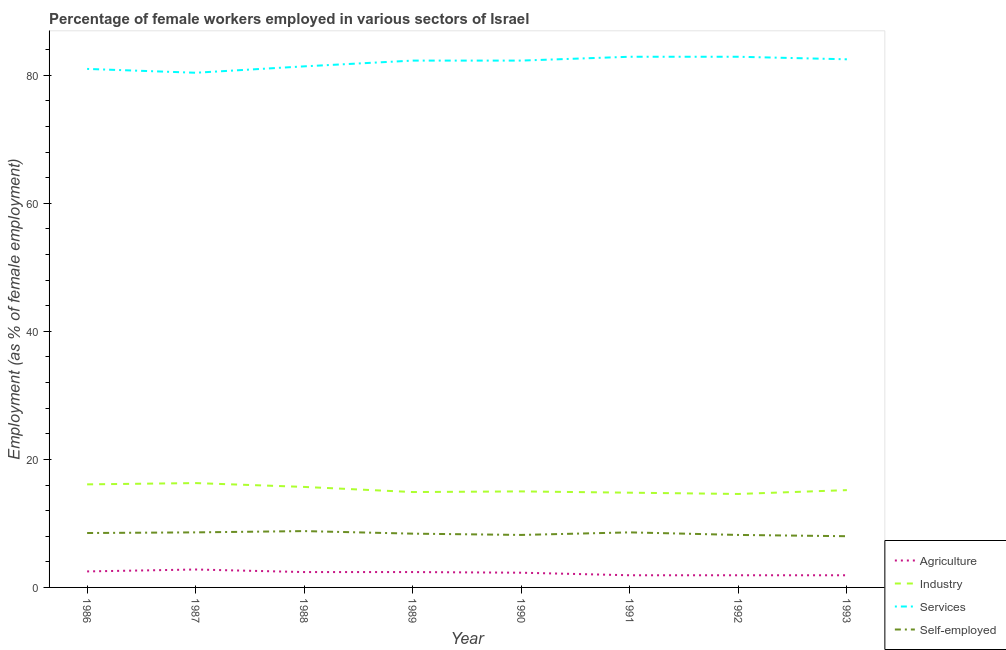How many different coloured lines are there?
Your answer should be very brief. 4. Is the number of lines equal to the number of legend labels?
Keep it short and to the point. Yes. What is the percentage of female workers in industry in 1991?
Your response must be concise. 14.8. Across all years, what is the maximum percentage of female workers in industry?
Provide a succinct answer. 16.3. What is the total percentage of female workers in industry in the graph?
Offer a terse response. 122.6. What is the difference between the percentage of self employed female workers in 1991 and that in 1993?
Give a very brief answer. 0.6. What is the difference between the percentage of self employed female workers in 1992 and the percentage of female workers in services in 1993?
Provide a short and direct response. -74.3. What is the average percentage of female workers in agriculture per year?
Your answer should be compact. 2.26. In the year 1992, what is the difference between the percentage of female workers in services and percentage of female workers in industry?
Make the answer very short. 68.3. What is the ratio of the percentage of female workers in agriculture in 1987 to that in 1990?
Make the answer very short. 1.22. Is the difference between the percentage of female workers in industry in 1986 and 1991 greater than the difference between the percentage of female workers in agriculture in 1986 and 1991?
Keep it short and to the point. Yes. What is the difference between the highest and the second highest percentage of female workers in services?
Offer a terse response. 0. What is the difference between the highest and the lowest percentage of female workers in services?
Keep it short and to the point. 2.5. In how many years, is the percentage of female workers in services greater than the average percentage of female workers in services taken over all years?
Provide a succinct answer. 5. Is the sum of the percentage of female workers in agriculture in 1988 and 1989 greater than the maximum percentage of self employed female workers across all years?
Your response must be concise. No. Is it the case that in every year, the sum of the percentage of female workers in agriculture and percentage of self employed female workers is greater than the sum of percentage of female workers in industry and percentage of female workers in services?
Offer a very short reply. Yes. Is it the case that in every year, the sum of the percentage of female workers in agriculture and percentage of female workers in industry is greater than the percentage of female workers in services?
Provide a short and direct response. No. Does the percentage of female workers in industry monotonically increase over the years?
Offer a terse response. No. Is the percentage of female workers in industry strictly less than the percentage of female workers in agriculture over the years?
Your answer should be compact. No. What is the difference between two consecutive major ticks on the Y-axis?
Give a very brief answer. 20. Are the values on the major ticks of Y-axis written in scientific E-notation?
Provide a succinct answer. No. Does the graph contain any zero values?
Provide a succinct answer. No. Does the graph contain grids?
Make the answer very short. No. How many legend labels are there?
Provide a succinct answer. 4. What is the title of the graph?
Give a very brief answer. Percentage of female workers employed in various sectors of Israel. What is the label or title of the X-axis?
Your answer should be very brief. Year. What is the label or title of the Y-axis?
Make the answer very short. Employment (as % of female employment). What is the Employment (as % of female employment) of Industry in 1986?
Your answer should be compact. 16.1. What is the Employment (as % of female employment) in Agriculture in 1987?
Offer a very short reply. 2.8. What is the Employment (as % of female employment) of Industry in 1987?
Your answer should be compact. 16.3. What is the Employment (as % of female employment) in Services in 1987?
Make the answer very short. 80.4. What is the Employment (as % of female employment) of Self-employed in 1987?
Your response must be concise. 8.6. What is the Employment (as % of female employment) in Agriculture in 1988?
Your answer should be compact. 2.4. What is the Employment (as % of female employment) of Industry in 1988?
Offer a very short reply. 15.7. What is the Employment (as % of female employment) of Services in 1988?
Provide a short and direct response. 81.4. What is the Employment (as % of female employment) of Self-employed in 1988?
Your response must be concise. 8.8. What is the Employment (as % of female employment) of Agriculture in 1989?
Provide a succinct answer. 2.4. What is the Employment (as % of female employment) in Industry in 1989?
Give a very brief answer. 14.9. What is the Employment (as % of female employment) of Services in 1989?
Make the answer very short. 82.3. What is the Employment (as % of female employment) in Self-employed in 1989?
Offer a very short reply. 8.4. What is the Employment (as % of female employment) of Agriculture in 1990?
Keep it short and to the point. 2.3. What is the Employment (as % of female employment) of Services in 1990?
Provide a succinct answer. 82.3. What is the Employment (as % of female employment) in Self-employed in 1990?
Give a very brief answer. 8.2. What is the Employment (as % of female employment) of Agriculture in 1991?
Make the answer very short. 1.9. What is the Employment (as % of female employment) of Industry in 1991?
Make the answer very short. 14.8. What is the Employment (as % of female employment) in Services in 1991?
Your response must be concise. 82.9. What is the Employment (as % of female employment) of Self-employed in 1991?
Your answer should be very brief. 8.6. What is the Employment (as % of female employment) in Agriculture in 1992?
Offer a terse response. 1.9. What is the Employment (as % of female employment) of Industry in 1992?
Make the answer very short. 14.6. What is the Employment (as % of female employment) of Services in 1992?
Your answer should be compact. 82.9. What is the Employment (as % of female employment) of Self-employed in 1992?
Offer a very short reply. 8.2. What is the Employment (as % of female employment) of Agriculture in 1993?
Your response must be concise. 1.9. What is the Employment (as % of female employment) in Industry in 1993?
Your answer should be very brief. 15.2. What is the Employment (as % of female employment) of Services in 1993?
Provide a short and direct response. 82.5. What is the Employment (as % of female employment) in Self-employed in 1993?
Give a very brief answer. 8. Across all years, what is the maximum Employment (as % of female employment) of Agriculture?
Offer a very short reply. 2.8. Across all years, what is the maximum Employment (as % of female employment) in Industry?
Your answer should be very brief. 16.3. Across all years, what is the maximum Employment (as % of female employment) in Services?
Offer a terse response. 82.9. Across all years, what is the maximum Employment (as % of female employment) in Self-employed?
Your answer should be very brief. 8.8. Across all years, what is the minimum Employment (as % of female employment) in Agriculture?
Keep it short and to the point. 1.9. Across all years, what is the minimum Employment (as % of female employment) of Industry?
Provide a short and direct response. 14.6. Across all years, what is the minimum Employment (as % of female employment) in Services?
Offer a very short reply. 80.4. What is the total Employment (as % of female employment) in Agriculture in the graph?
Offer a very short reply. 18.1. What is the total Employment (as % of female employment) of Industry in the graph?
Your response must be concise. 122.6. What is the total Employment (as % of female employment) in Services in the graph?
Provide a short and direct response. 655.7. What is the total Employment (as % of female employment) in Self-employed in the graph?
Provide a succinct answer. 67.3. What is the difference between the Employment (as % of female employment) in Industry in 1986 and that in 1987?
Your answer should be very brief. -0.2. What is the difference between the Employment (as % of female employment) of Self-employed in 1986 and that in 1987?
Give a very brief answer. -0.1. What is the difference between the Employment (as % of female employment) of Agriculture in 1986 and that in 1988?
Keep it short and to the point. 0.1. What is the difference between the Employment (as % of female employment) in Industry in 1986 and that in 1988?
Provide a succinct answer. 0.4. What is the difference between the Employment (as % of female employment) in Industry in 1986 and that in 1990?
Your response must be concise. 1.1. What is the difference between the Employment (as % of female employment) in Services in 1986 and that in 1990?
Ensure brevity in your answer.  -1.3. What is the difference between the Employment (as % of female employment) of Industry in 1986 and that in 1991?
Make the answer very short. 1.3. What is the difference between the Employment (as % of female employment) of Self-employed in 1986 and that in 1991?
Provide a short and direct response. -0.1. What is the difference between the Employment (as % of female employment) in Agriculture in 1986 and that in 1992?
Offer a very short reply. 0.6. What is the difference between the Employment (as % of female employment) in Services in 1986 and that in 1992?
Your answer should be very brief. -1.9. What is the difference between the Employment (as % of female employment) of Services in 1986 and that in 1993?
Make the answer very short. -1.5. What is the difference between the Employment (as % of female employment) in Agriculture in 1987 and that in 1988?
Ensure brevity in your answer.  0.4. What is the difference between the Employment (as % of female employment) in Industry in 1987 and that in 1988?
Keep it short and to the point. 0.6. What is the difference between the Employment (as % of female employment) of Self-employed in 1987 and that in 1988?
Ensure brevity in your answer.  -0.2. What is the difference between the Employment (as % of female employment) of Industry in 1987 and that in 1989?
Ensure brevity in your answer.  1.4. What is the difference between the Employment (as % of female employment) of Self-employed in 1987 and that in 1989?
Your answer should be compact. 0.2. What is the difference between the Employment (as % of female employment) in Industry in 1987 and that in 1990?
Provide a short and direct response. 1.3. What is the difference between the Employment (as % of female employment) of Industry in 1987 and that in 1991?
Your response must be concise. 1.5. What is the difference between the Employment (as % of female employment) of Services in 1987 and that in 1991?
Your response must be concise. -2.5. What is the difference between the Employment (as % of female employment) in Self-employed in 1987 and that in 1991?
Your answer should be compact. 0. What is the difference between the Employment (as % of female employment) in Agriculture in 1987 and that in 1992?
Offer a very short reply. 0.9. What is the difference between the Employment (as % of female employment) in Industry in 1987 and that in 1992?
Ensure brevity in your answer.  1.7. What is the difference between the Employment (as % of female employment) in Services in 1987 and that in 1992?
Ensure brevity in your answer.  -2.5. What is the difference between the Employment (as % of female employment) in Agriculture in 1987 and that in 1993?
Your answer should be very brief. 0.9. What is the difference between the Employment (as % of female employment) of Industry in 1987 and that in 1993?
Provide a short and direct response. 1.1. What is the difference between the Employment (as % of female employment) of Self-employed in 1987 and that in 1993?
Provide a succinct answer. 0.6. What is the difference between the Employment (as % of female employment) in Industry in 1988 and that in 1989?
Your response must be concise. 0.8. What is the difference between the Employment (as % of female employment) in Industry in 1988 and that in 1991?
Give a very brief answer. 0.9. What is the difference between the Employment (as % of female employment) in Self-employed in 1988 and that in 1991?
Make the answer very short. 0.2. What is the difference between the Employment (as % of female employment) in Services in 1988 and that in 1992?
Ensure brevity in your answer.  -1.5. What is the difference between the Employment (as % of female employment) in Self-employed in 1988 and that in 1992?
Give a very brief answer. 0.6. What is the difference between the Employment (as % of female employment) of Agriculture in 1988 and that in 1993?
Give a very brief answer. 0.5. What is the difference between the Employment (as % of female employment) of Self-employed in 1988 and that in 1993?
Offer a very short reply. 0.8. What is the difference between the Employment (as % of female employment) in Services in 1989 and that in 1990?
Offer a very short reply. 0. What is the difference between the Employment (as % of female employment) in Agriculture in 1989 and that in 1991?
Make the answer very short. 0.5. What is the difference between the Employment (as % of female employment) in Self-employed in 1989 and that in 1991?
Your response must be concise. -0.2. What is the difference between the Employment (as % of female employment) in Agriculture in 1989 and that in 1992?
Provide a succinct answer. 0.5. What is the difference between the Employment (as % of female employment) in Agriculture in 1989 and that in 1993?
Your response must be concise. 0.5. What is the difference between the Employment (as % of female employment) in Services in 1989 and that in 1993?
Keep it short and to the point. -0.2. What is the difference between the Employment (as % of female employment) of Industry in 1990 and that in 1991?
Offer a very short reply. 0.2. What is the difference between the Employment (as % of female employment) of Services in 1990 and that in 1992?
Your response must be concise. -0.6. What is the difference between the Employment (as % of female employment) in Self-employed in 1990 and that in 1992?
Provide a succinct answer. 0. What is the difference between the Employment (as % of female employment) in Industry in 1990 and that in 1993?
Offer a very short reply. -0.2. What is the difference between the Employment (as % of female employment) of Services in 1991 and that in 1992?
Provide a short and direct response. 0. What is the difference between the Employment (as % of female employment) of Self-employed in 1991 and that in 1992?
Ensure brevity in your answer.  0.4. What is the difference between the Employment (as % of female employment) in Industry in 1991 and that in 1993?
Your answer should be compact. -0.4. What is the difference between the Employment (as % of female employment) in Services in 1992 and that in 1993?
Keep it short and to the point. 0.4. What is the difference between the Employment (as % of female employment) in Agriculture in 1986 and the Employment (as % of female employment) in Industry in 1987?
Provide a succinct answer. -13.8. What is the difference between the Employment (as % of female employment) in Agriculture in 1986 and the Employment (as % of female employment) in Services in 1987?
Ensure brevity in your answer.  -77.9. What is the difference between the Employment (as % of female employment) in Agriculture in 1986 and the Employment (as % of female employment) in Self-employed in 1987?
Offer a terse response. -6.1. What is the difference between the Employment (as % of female employment) of Industry in 1986 and the Employment (as % of female employment) of Services in 1987?
Give a very brief answer. -64.3. What is the difference between the Employment (as % of female employment) in Services in 1986 and the Employment (as % of female employment) in Self-employed in 1987?
Provide a succinct answer. 72.4. What is the difference between the Employment (as % of female employment) of Agriculture in 1986 and the Employment (as % of female employment) of Industry in 1988?
Your answer should be very brief. -13.2. What is the difference between the Employment (as % of female employment) in Agriculture in 1986 and the Employment (as % of female employment) in Services in 1988?
Give a very brief answer. -78.9. What is the difference between the Employment (as % of female employment) in Industry in 1986 and the Employment (as % of female employment) in Services in 1988?
Your response must be concise. -65.3. What is the difference between the Employment (as % of female employment) of Services in 1986 and the Employment (as % of female employment) of Self-employed in 1988?
Provide a short and direct response. 72.2. What is the difference between the Employment (as % of female employment) in Agriculture in 1986 and the Employment (as % of female employment) in Services in 1989?
Ensure brevity in your answer.  -79.8. What is the difference between the Employment (as % of female employment) in Agriculture in 1986 and the Employment (as % of female employment) in Self-employed in 1989?
Give a very brief answer. -5.9. What is the difference between the Employment (as % of female employment) in Industry in 1986 and the Employment (as % of female employment) in Services in 1989?
Provide a succinct answer. -66.2. What is the difference between the Employment (as % of female employment) of Services in 1986 and the Employment (as % of female employment) of Self-employed in 1989?
Your answer should be very brief. 72.6. What is the difference between the Employment (as % of female employment) in Agriculture in 1986 and the Employment (as % of female employment) in Industry in 1990?
Ensure brevity in your answer.  -12.5. What is the difference between the Employment (as % of female employment) of Agriculture in 1986 and the Employment (as % of female employment) of Services in 1990?
Provide a short and direct response. -79.8. What is the difference between the Employment (as % of female employment) in Agriculture in 1986 and the Employment (as % of female employment) in Self-employed in 1990?
Give a very brief answer. -5.7. What is the difference between the Employment (as % of female employment) in Industry in 1986 and the Employment (as % of female employment) in Services in 1990?
Provide a succinct answer. -66.2. What is the difference between the Employment (as % of female employment) in Industry in 1986 and the Employment (as % of female employment) in Self-employed in 1990?
Your response must be concise. 7.9. What is the difference between the Employment (as % of female employment) of Services in 1986 and the Employment (as % of female employment) of Self-employed in 1990?
Your answer should be very brief. 72.8. What is the difference between the Employment (as % of female employment) in Agriculture in 1986 and the Employment (as % of female employment) in Industry in 1991?
Keep it short and to the point. -12.3. What is the difference between the Employment (as % of female employment) in Agriculture in 1986 and the Employment (as % of female employment) in Services in 1991?
Your response must be concise. -80.4. What is the difference between the Employment (as % of female employment) in Agriculture in 1986 and the Employment (as % of female employment) in Self-employed in 1991?
Make the answer very short. -6.1. What is the difference between the Employment (as % of female employment) in Industry in 1986 and the Employment (as % of female employment) in Services in 1991?
Provide a short and direct response. -66.8. What is the difference between the Employment (as % of female employment) in Services in 1986 and the Employment (as % of female employment) in Self-employed in 1991?
Make the answer very short. 72.4. What is the difference between the Employment (as % of female employment) in Agriculture in 1986 and the Employment (as % of female employment) in Services in 1992?
Your answer should be very brief. -80.4. What is the difference between the Employment (as % of female employment) in Agriculture in 1986 and the Employment (as % of female employment) in Self-employed in 1992?
Give a very brief answer. -5.7. What is the difference between the Employment (as % of female employment) of Industry in 1986 and the Employment (as % of female employment) of Services in 1992?
Offer a very short reply. -66.8. What is the difference between the Employment (as % of female employment) in Services in 1986 and the Employment (as % of female employment) in Self-employed in 1992?
Give a very brief answer. 72.8. What is the difference between the Employment (as % of female employment) in Agriculture in 1986 and the Employment (as % of female employment) in Services in 1993?
Offer a terse response. -80. What is the difference between the Employment (as % of female employment) in Industry in 1986 and the Employment (as % of female employment) in Services in 1993?
Offer a very short reply. -66.4. What is the difference between the Employment (as % of female employment) in Agriculture in 1987 and the Employment (as % of female employment) in Industry in 1988?
Make the answer very short. -12.9. What is the difference between the Employment (as % of female employment) of Agriculture in 1987 and the Employment (as % of female employment) of Services in 1988?
Offer a terse response. -78.6. What is the difference between the Employment (as % of female employment) of Agriculture in 1987 and the Employment (as % of female employment) of Self-employed in 1988?
Provide a short and direct response. -6. What is the difference between the Employment (as % of female employment) in Industry in 1987 and the Employment (as % of female employment) in Services in 1988?
Provide a short and direct response. -65.1. What is the difference between the Employment (as % of female employment) in Industry in 1987 and the Employment (as % of female employment) in Self-employed in 1988?
Offer a very short reply. 7.5. What is the difference between the Employment (as % of female employment) in Services in 1987 and the Employment (as % of female employment) in Self-employed in 1988?
Offer a terse response. 71.6. What is the difference between the Employment (as % of female employment) of Agriculture in 1987 and the Employment (as % of female employment) of Services in 1989?
Your answer should be very brief. -79.5. What is the difference between the Employment (as % of female employment) of Industry in 1987 and the Employment (as % of female employment) of Services in 1989?
Provide a short and direct response. -66. What is the difference between the Employment (as % of female employment) of Agriculture in 1987 and the Employment (as % of female employment) of Services in 1990?
Make the answer very short. -79.5. What is the difference between the Employment (as % of female employment) in Industry in 1987 and the Employment (as % of female employment) in Services in 1990?
Your response must be concise. -66. What is the difference between the Employment (as % of female employment) in Services in 1987 and the Employment (as % of female employment) in Self-employed in 1990?
Offer a very short reply. 72.2. What is the difference between the Employment (as % of female employment) in Agriculture in 1987 and the Employment (as % of female employment) in Services in 1991?
Keep it short and to the point. -80.1. What is the difference between the Employment (as % of female employment) in Industry in 1987 and the Employment (as % of female employment) in Services in 1991?
Your response must be concise. -66.6. What is the difference between the Employment (as % of female employment) of Industry in 1987 and the Employment (as % of female employment) of Self-employed in 1991?
Provide a succinct answer. 7.7. What is the difference between the Employment (as % of female employment) in Services in 1987 and the Employment (as % of female employment) in Self-employed in 1991?
Your response must be concise. 71.8. What is the difference between the Employment (as % of female employment) in Agriculture in 1987 and the Employment (as % of female employment) in Services in 1992?
Provide a succinct answer. -80.1. What is the difference between the Employment (as % of female employment) of Agriculture in 1987 and the Employment (as % of female employment) of Self-employed in 1992?
Provide a short and direct response. -5.4. What is the difference between the Employment (as % of female employment) in Industry in 1987 and the Employment (as % of female employment) in Services in 1992?
Make the answer very short. -66.6. What is the difference between the Employment (as % of female employment) in Industry in 1987 and the Employment (as % of female employment) in Self-employed in 1992?
Your answer should be very brief. 8.1. What is the difference between the Employment (as % of female employment) of Services in 1987 and the Employment (as % of female employment) of Self-employed in 1992?
Offer a terse response. 72.2. What is the difference between the Employment (as % of female employment) in Agriculture in 1987 and the Employment (as % of female employment) in Industry in 1993?
Your response must be concise. -12.4. What is the difference between the Employment (as % of female employment) of Agriculture in 1987 and the Employment (as % of female employment) of Services in 1993?
Provide a short and direct response. -79.7. What is the difference between the Employment (as % of female employment) in Agriculture in 1987 and the Employment (as % of female employment) in Self-employed in 1993?
Your answer should be compact. -5.2. What is the difference between the Employment (as % of female employment) in Industry in 1987 and the Employment (as % of female employment) in Services in 1993?
Provide a succinct answer. -66.2. What is the difference between the Employment (as % of female employment) of Services in 1987 and the Employment (as % of female employment) of Self-employed in 1993?
Make the answer very short. 72.4. What is the difference between the Employment (as % of female employment) in Agriculture in 1988 and the Employment (as % of female employment) in Services in 1989?
Provide a succinct answer. -79.9. What is the difference between the Employment (as % of female employment) of Agriculture in 1988 and the Employment (as % of female employment) of Self-employed in 1989?
Provide a short and direct response. -6. What is the difference between the Employment (as % of female employment) of Industry in 1988 and the Employment (as % of female employment) of Services in 1989?
Keep it short and to the point. -66.6. What is the difference between the Employment (as % of female employment) of Industry in 1988 and the Employment (as % of female employment) of Self-employed in 1989?
Provide a short and direct response. 7.3. What is the difference between the Employment (as % of female employment) of Services in 1988 and the Employment (as % of female employment) of Self-employed in 1989?
Make the answer very short. 73. What is the difference between the Employment (as % of female employment) of Agriculture in 1988 and the Employment (as % of female employment) of Services in 1990?
Make the answer very short. -79.9. What is the difference between the Employment (as % of female employment) of Industry in 1988 and the Employment (as % of female employment) of Services in 1990?
Offer a very short reply. -66.6. What is the difference between the Employment (as % of female employment) of Services in 1988 and the Employment (as % of female employment) of Self-employed in 1990?
Your answer should be compact. 73.2. What is the difference between the Employment (as % of female employment) of Agriculture in 1988 and the Employment (as % of female employment) of Services in 1991?
Make the answer very short. -80.5. What is the difference between the Employment (as % of female employment) in Industry in 1988 and the Employment (as % of female employment) in Services in 1991?
Your answer should be very brief. -67.2. What is the difference between the Employment (as % of female employment) of Industry in 1988 and the Employment (as % of female employment) of Self-employed in 1991?
Offer a terse response. 7.1. What is the difference between the Employment (as % of female employment) of Services in 1988 and the Employment (as % of female employment) of Self-employed in 1991?
Your response must be concise. 72.8. What is the difference between the Employment (as % of female employment) in Agriculture in 1988 and the Employment (as % of female employment) in Services in 1992?
Provide a short and direct response. -80.5. What is the difference between the Employment (as % of female employment) of Agriculture in 1988 and the Employment (as % of female employment) of Self-employed in 1992?
Your answer should be very brief. -5.8. What is the difference between the Employment (as % of female employment) in Industry in 1988 and the Employment (as % of female employment) in Services in 1992?
Make the answer very short. -67.2. What is the difference between the Employment (as % of female employment) in Services in 1988 and the Employment (as % of female employment) in Self-employed in 1992?
Your answer should be very brief. 73.2. What is the difference between the Employment (as % of female employment) of Agriculture in 1988 and the Employment (as % of female employment) of Industry in 1993?
Provide a succinct answer. -12.8. What is the difference between the Employment (as % of female employment) in Agriculture in 1988 and the Employment (as % of female employment) in Services in 1993?
Provide a succinct answer. -80.1. What is the difference between the Employment (as % of female employment) of Agriculture in 1988 and the Employment (as % of female employment) of Self-employed in 1993?
Your answer should be very brief. -5.6. What is the difference between the Employment (as % of female employment) of Industry in 1988 and the Employment (as % of female employment) of Services in 1993?
Provide a succinct answer. -66.8. What is the difference between the Employment (as % of female employment) in Industry in 1988 and the Employment (as % of female employment) in Self-employed in 1993?
Ensure brevity in your answer.  7.7. What is the difference between the Employment (as % of female employment) of Services in 1988 and the Employment (as % of female employment) of Self-employed in 1993?
Offer a very short reply. 73.4. What is the difference between the Employment (as % of female employment) in Agriculture in 1989 and the Employment (as % of female employment) in Industry in 1990?
Provide a succinct answer. -12.6. What is the difference between the Employment (as % of female employment) in Agriculture in 1989 and the Employment (as % of female employment) in Services in 1990?
Provide a short and direct response. -79.9. What is the difference between the Employment (as % of female employment) of Industry in 1989 and the Employment (as % of female employment) of Services in 1990?
Offer a very short reply. -67.4. What is the difference between the Employment (as % of female employment) in Services in 1989 and the Employment (as % of female employment) in Self-employed in 1990?
Offer a terse response. 74.1. What is the difference between the Employment (as % of female employment) of Agriculture in 1989 and the Employment (as % of female employment) of Services in 1991?
Offer a very short reply. -80.5. What is the difference between the Employment (as % of female employment) of Industry in 1989 and the Employment (as % of female employment) of Services in 1991?
Provide a succinct answer. -68. What is the difference between the Employment (as % of female employment) of Services in 1989 and the Employment (as % of female employment) of Self-employed in 1991?
Offer a very short reply. 73.7. What is the difference between the Employment (as % of female employment) in Agriculture in 1989 and the Employment (as % of female employment) in Services in 1992?
Provide a short and direct response. -80.5. What is the difference between the Employment (as % of female employment) of Agriculture in 1989 and the Employment (as % of female employment) of Self-employed in 1992?
Your answer should be very brief. -5.8. What is the difference between the Employment (as % of female employment) in Industry in 1989 and the Employment (as % of female employment) in Services in 1992?
Make the answer very short. -68. What is the difference between the Employment (as % of female employment) in Industry in 1989 and the Employment (as % of female employment) in Self-employed in 1992?
Offer a very short reply. 6.7. What is the difference between the Employment (as % of female employment) in Services in 1989 and the Employment (as % of female employment) in Self-employed in 1992?
Give a very brief answer. 74.1. What is the difference between the Employment (as % of female employment) of Agriculture in 1989 and the Employment (as % of female employment) of Services in 1993?
Give a very brief answer. -80.1. What is the difference between the Employment (as % of female employment) in Agriculture in 1989 and the Employment (as % of female employment) in Self-employed in 1993?
Make the answer very short. -5.6. What is the difference between the Employment (as % of female employment) in Industry in 1989 and the Employment (as % of female employment) in Services in 1993?
Offer a terse response. -67.6. What is the difference between the Employment (as % of female employment) of Services in 1989 and the Employment (as % of female employment) of Self-employed in 1993?
Your response must be concise. 74.3. What is the difference between the Employment (as % of female employment) of Agriculture in 1990 and the Employment (as % of female employment) of Industry in 1991?
Give a very brief answer. -12.5. What is the difference between the Employment (as % of female employment) in Agriculture in 1990 and the Employment (as % of female employment) in Services in 1991?
Provide a short and direct response. -80.6. What is the difference between the Employment (as % of female employment) of Agriculture in 1990 and the Employment (as % of female employment) of Self-employed in 1991?
Provide a short and direct response. -6.3. What is the difference between the Employment (as % of female employment) in Industry in 1990 and the Employment (as % of female employment) in Services in 1991?
Offer a terse response. -67.9. What is the difference between the Employment (as % of female employment) of Services in 1990 and the Employment (as % of female employment) of Self-employed in 1991?
Offer a terse response. 73.7. What is the difference between the Employment (as % of female employment) in Agriculture in 1990 and the Employment (as % of female employment) in Services in 1992?
Make the answer very short. -80.6. What is the difference between the Employment (as % of female employment) in Industry in 1990 and the Employment (as % of female employment) in Services in 1992?
Make the answer very short. -67.9. What is the difference between the Employment (as % of female employment) in Services in 1990 and the Employment (as % of female employment) in Self-employed in 1992?
Provide a short and direct response. 74.1. What is the difference between the Employment (as % of female employment) of Agriculture in 1990 and the Employment (as % of female employment) of Industry in 1993?
Provide a succinct answer. -12.9. What is the difference between the Employment (as % of female employment) in Agriculture in 1990 and the Employment (as % of female employment) in Services in 1993?
Keep it short and to the point. -80.2. What is the difference between the Employment (as % of female employment) of Industry in 1990 and the Employment (as % of female employment) of Services in 1993?
Keep it short and to the point. -67.5. What is the difference between the Employment (as % of female employment) of Services in 1990 and the Employment (as % of female employment) of Self-employed in 1993?
Your answer should be very brief. 74.3. What is the difference between the Employment (as % of female employment) of Agriculture in 1991 and the Employment (as % of female employment) of Services in 1992?
Ensure brevity in your answer.  -81. What is the difference between the Employment (as % of female employment) in Agriculture in 1991 and the Employment (as % of female employment) in Self-employed in 1992?
Offer a very short reply. -6.3. What is the difference between the Employment (as % of female employment) in Industry in 1991 and the Employment (as % of female employment) in Services in 1992?
Provide a succinct answer. -68.1. What is the difference between the Employment (as % of female employment) in Services in 1991 and the Employment (as % of female employment) in Self-employed in 1992?
Offer a very short reply. 74.7. What is the difference between the Employment (as % of female employment) in Agriculture in 1991 and the Employment (as % of female employment) in Services in 1993?
Provide a short and direct response. -80.6. What is the difference between the Employment (as % of female employment) in Industry in 1991 and the Employment (as % of female employment) in Services in 1993?
Ensure brevity in your answer.  -67.7. What is the difference between the Employment (as % of female employment) of Industry in 1991 and the Employment (as % of female employment) of Self-employed in 1993?
Your answer should be compact. 6.8. What is the difference between the Employment (as % of female employment) in Services in 1991 and the Employment (as % of female employment) in Self-employed in 1993?
Ensure brevity in your answer.  74.9. What is the difference between the Employment (as % of female employment) of Agriculture in 1992 and the Employment (as % of female employment) of Services in 1993?
Your answer should be very brief. -80.6. What is the difference between the Employment (as % of female employment) in Industry in 1992 and the Employment (as % of female employment) in Services in 1993?
Make the answer very short. -67.9. What is the difference between the Employment (as % of female employment) of Services in 1992 and the Employment (as % of female employment) of Self-employed in 1993?
Ensure brevity in your answer.  74.9. What is the average Employment (as % of female employment) of Agriculture per year?
Provide a short and direct response. 2.26. What is the average Employment (as % of female employment) of Industry per year?
Offer a very short reply. 15.32. What is the average Employment (as % of female employment) in Services per year?
Offer a very short reply. 81.96. What is the average Employment (as % of female employment) in Self-employed per year?
Provide a succinct answer. 8.41. In the year 1986, what is the difference between the Employment (as % of female employment) of Agriculture and Employment (as % of female employment) of Services?
Ensure brevity in your answer.  -78.5. In the year 1986, what is the difference between the Employment (as % of female employment) in Industry and Employment (as % of female employment) in Services?
Offer a terse response. -64.9. In the year 1986, what is the difference between the Employment (as % of female employment) in Industry and Employment (as % of female employment) in Self-employed?
Give a very brief answer. 7.6. In the year 1986, what is the difference between the Employment (as % of female employment) in Services and Employment (as % of female employment) in Self-employed?
Your answer should be very brief. 72.5. In the year 1987, what is the difference between the Employment (as % of female employment) of Agriculture and Employment (as % of female employment) of Services?
Provide a short and direct response. -77.6. In the year 1987, what is the difference between the Employment (as % of female employment) in Industry and Employment (as % of female employment) in Services?
Keep it short and to the point. -64.1. In the year 1987, what is the difference between the Employment (as % of female employment) in Services and Employment (as % of female employment) in Self-employed?
Provide a short and direct response. 71.8. In the year 1988, what is the difference between the Employment (as % of female employment) in Agriculture and Employment (as % of female employment) in Industry?
Offer a very short reply. -13.3. In the year 1988, what is the difference between the Employment (as % of female employment) in Agriculture and Employment (as % of female employment) in Services?
Offer a very short reply. -79. In the year 1988, what is the difference between the Employment (as % of female employment) in Agriculture and Employment (as % of female employment) in Self-employed?
Provide a short and direct response. -6.4. In the year 1988, what is the difference between the Employment (as % of female employment) in Industry and Employment (as % of female employment) in Services?
Your answer should be very brief. -65.7. In the year 1988, what is the difference between the Employment (as % of female employment) of Services and Employment (as % of female employment) of Self-employed?
Your answer should be very brief. 72.6. In the year 1989, what is the difference between the Employment (as % of female employment) of Agriculture and Employment (as % of female employment) of Industry?
Give a very brief answer. -12.5. In the year 1989, what is the difference between the Employment (as % of female employment) of Agriculture and Employment (as % of female employment) of Services?
Keep it short and to the point. -79.9. In the year 1989, what is the difference between the Employment (as % of female employment) of Agriculture and Employment (as % of female employment) of Self-employed?
Provide a succinct answer. -6. In the year 1989, what is the difference between the Employment (as % of female employment) in Industry and Employment (as % of female employment) in Services?
Keep it short and to the point. -67.4. In the year 1989, what is the difference between the Employment (as % of female employment) of Services and Employment (as % of female employment) of Self-employed?
Offer a very short reply. 73.9. In the year 1990, what is the difference between the Employment (as % of female employment) of Agriculture and Employment (as % of female employment) of Services?
Your response must be concise. -80. In the year 1990, what is the difference between the Employment (as % of female employment) of Industry and Employment (as % of female employment) of Services?
Provide a short and direct response. -67.3. In the year 1990, what is the difference between the Employment (as % of female employment) of Services and Employment (as % of female employment) of Self-employed?
Provide a short and direct response. 74.1. In the year 1991, what is the difference between the Employment (as % of female employment) in Agriculture and Employment (as % of female employment) in Services?
Make the answer very short. -81. In the year 1991, what is the difference between the Employment (as % of female employment) of Agriculture and Employment (as % of female employment) of Self-employed?
Ensure brevity in your answer.  -6.7. In the year 1991, what is the difference between the Employment (as % of female employment) in Industry and Employment (as % of female employment) in Services?
Your answer should be compact. -68.1. In the year 1991, what is the difference between the Employment (as % of female employment) of Services and Employment (as % of female employment) of Self-employed?
Your answer should be very brief. 74.3. In the year 1992, what is the difference between the Employment (as % of female employment) in Agriculture and Employment (as % of female employment) in Industry?
Your answer should be very brief. -12.7. In the year 1992, what is the difference between the Employment (as % of female employment) in Agriculture and Employment (as % of female employment) in Services?
Keep it short and to the point. -81. In the year 1992, what is the difference between the Employment (as % of female employment) in Agriculture and Employment (as % of female employment) in Self-employed?
Provide a succinct answer. -6.3. In the year 1992, what is the difference between the Employment (as % of female employment) in Industry and Employment (as % of female employment) in Services?
Offer a very short reply. -68.3. In the year 1992, what is the difference between the Employment (as % of female employment) in Industry and Employment (as % of female employment) in Self-employed?
Make the answer very short. 6.4. In the year 1992, what is the difference between the Employment (as % of female employment) of Services and Employment (as % of female employment) of Self-employed?
Your answer should be compact. 74.7. In the year 1993, what is the difference between the Employment (as % of female employment) in Agriculture and Employment (as % of female employment) in Services?
Make the answer very short. -80.6. In the year 1993, what is the difference between the Employment (as % of female employment) of Agriculture and Employment (as % of female employment) of Self-employed?
Offer a terse response. -6.1. In the year 1993, what is the difference between the Employment (as % of female employment) in Industry and Employment (as % of female employment) in Services?
Ensure brevity in your answer.  -67.3. In the year 1993, what is the difference between the Employment (as % of female employment) in Industry and Employment (as % of female employment) in Self-employed?
Give a very brief answer. 7.2. In the year 1993, what is the difference between the Employment (as % of female employment) of Services and Employment (as % of female employment) of Self-employed?
Your answer should be very brief. 74.5. What is the ratio of the Employment (as % of female employment) in Agriculture in 1986 to that in 1987?
Ensure brevity in your answer.  0.89. What is the ratio of the Employment (as % of female employment) in Services in 1986 to that in 1987?
Provide a succinct answer. 1.01. What is the ratio of the Employment (as % of female employment) of Self-employed in 1986 to that in 1987?
Provide a short and direct response. 0.99. What is the ratio of the Employment (as % of female employment) of Agriculture in 1986 to that in 1988?
Offer a very short reply. 1.04. What is the ratio of the Employment (as % of female employment) in Industry in 1986 to that in 1988?
Your response must be concise. 1.03. What is the ratio of the Employment (as % of female employment) in Self-employed in 1986 to that in 1988?
Offer a terse response. 0.97. What is the ratio of the Employment (as % of female employment) of Agriculture in 1986 to that in 1989?
Your answer should be very brief. 1.04. What is the ratio of the Employment (as % of female employment) of Industry in 1986 to that in 1989?
Provide a succinct answer. 1.08. What is the ratio of the Employment (as % of female employment) in Services in 1986 to that in 1989?
Offer a very short reply. 0.98. What is the ratio of the Employment (as % of female employment) of Self-employed in 1986 to that in 1989?
Offer a terse response. 1.01. What is the ratio of the Employment (as % of female employment) of Agriculture in 1986 to that in 1990?
Provide a succinct answer. 1.09. What is the ratio of the Employment (as % of female employment) of Industry in 1986 to that in 1990?
Provide a short and direct response. 1.07. What is the ratio of the Employment (as % of female employment) in Services in 1986 to that in 1990?
Keep it short and to the point. 0.98. What is the ratio of the Employment (as % of female employment) in Self-employed in 1986 to that in 1990?
Give a very brief answer. 1.04. What is the ratio of the Employment (as % of female employment) in Agriculture in 1986 to that in 1991?
Offer a terse response. 1.32. What is the ratio of the Employment (as % of female employment) in Industry in 1986 to that in 1991?
Provide a succinct answer. 1.09. What is the ratio of the Employment (as % of female employment) of Services in 1986 to that in 1991?
Give a very brief answer. 0.98. What is the ratio of the Employment (as % of female employment) of Self-employed in 1986 to that in 1991?
Your answer should be very brief. 0.99. What is the ratio of the Employment (as % of female employment) of Agriculture in 1986 to that in 1992?
Your answer should be compact. 1.32. What is the ratio of the Employment (as % of female employment) of Industry in 1986 to that in 1992?
Provide a succinct answer. 1.1. What is the ratio of the Employment (as % of female employment) of Services in 1986 to that in 1992?
Keep it short and to the point. 0.98. What is the ratio of the Employment (as % of female employment) in Self-employed in 1986 to that in 1992?
Provide a short and direct response. 1.04. What is the ratio of the Employment (as % of female employment) in Agriculture in 1986 to that in 1993?
Ensure brevity in your answer.  1.32. What is the ratio of the Employment (as % of female employment) in Industry in 1986 to that in 1993?
Ensure brevity in your answer.  1.06. What is the ratio of the Employment (as % of female employment) of Services in 1986 to that in 1993?
Your answer should be compact. 0.98. What is the ratio of the Employment (as % of female employment) of Self-employed in 1986 to that in 1993?
Give a very brief answer. 1.06. What is the ratio of the Employment (as % of female employment) of Industry in 1987 to that in 1988?
Make the answer very short. 1.04. What is the ratio of the Employment (as % of female employment) in Self-employed in 1987 to that in 1988?
Your answer should be very brief. 0.98. What is the ratio of the Employment (as % of female employment) in Agriculture in 1987 to that in 1989?
Offer a terse response. 1.17. What is the ratio of the Employment (as % of female employment) of Industry in 1987 to that in 1989?
Your response must be concise. 1.09. What is the ratio of the Employment (as % of female employment) in Services in 1987 to that in 1989?
Keep it short and to the point. 0.98. What is the ratio of the Employment (as % of female employment) in Self-employed in 1987 to that in 1989?
Provide a succinct answer. 1.02. What is the ratio of the Employment (as % of female employment) of Agriculture in 1987 to that in 1990?
Make the answer very short. 1.22. What is the ratio of the Employment (as % of female employment) in Industry in 1987 to that in 1990?
Keep it short and to the point. 1.09. What is the ratio of the Employment (as % of female employment) in Services in 1987 to that in 1990?
Offer a very short reply. 0.98. What is the ratio of the Employment (as % of female employment) in Self-employed in 1987 to that in 1990?
Your answer should be compact. 1.05. What is the ratio of the Employment (as % of female employment) in Agriculture in 1987 to that in 1991?
Provide a short and direct response. 1.47. What is the ratio of the Employment (as % of female employment) in Industry in 1987 to that in 1991?
Your response must be concise. 1.1. What is the ratio of the Employment (as % of female employment) of Services in 1987 to that in 1991?
Give a very brief answer. 0.97. What is the ratio of the Employment (as % of female employment) in Agriculture in 1987 to that in 1992?
Give a very brief answer. 1.47. What is the ratio of the Employment (as % of female employment) of Industry in 1987 to that in 1992?
Ensure brevity in your answer.  1.12. What is the ratio of the Employment (as % of female employment) in Services in 1987 to that in 1992?
Your response must be concise. 0.97. What is the ratio of the Employment (as % of female employment) of Self-employed in 1987 to that in 1992?
Your response must be concise. 1.05. What is the ratio of the Employment (as % of female employment) in Agriculture in 1987 to that in 1993?
Ensure brevity in your answer.  1.47. What is the ratio of the Employment (as % of female employment) in Industry in 1987 to that in 1993?
Ensure brevity in your answer.  1.07. What is the ratio of the Employment (as % of female employment) in Services in 1987 to that in 1993?
Give a very brief answer. 0.97. What is the ratio of the Employment (as % of female employment) in Self-employed in 1987 to that in 1993?
Offer a very short reply. 1.07. What is the ratio of the Employment (as % of female employment) in Agriculture in 1988 to that in 1989?
Your answer should be compact. 1. What is the ratio of the Employment (as % of female employment) in Industry in 1988 to that in 1989?
Offer a very short reply. 1.05. What is the ratio of the Employment (as % of female employment) in Services in 1988 to that in 1989?
Provide a short and direct response. 0.99. What is the ratio of the Employment (as % of female employment) of Self-employed in 1988 to that in 1989?
Offer a terse response. 1.05. What is the ratio of the Employment (as % of female employment) of Agriculture in 1988 to that in 1990?
Your answer should be very brief. 1.04. What is the ratio of the Employment (as % of female employment) of Industry in 1988 to that in 1990?
Ensure brevity in your answer.  1.05. What is the ratio of the Employment (as % of female employment) of Services in 1988 to that in 1990?
Make the answer very short. 0.99. What is the ratio of the Employment (as % of female employment) of Self-employed in 1988 to that in 1990?
Your response must be concise. 1.07. What is the ratio of the Employment (as % of female employment) in Agriculture in 1988 to that in 1991?
Your response must be concise. 1.26. What is the ratio of the Employment (as % of female employment) of Industry in 1988 to that in 1991?
Offer a terse response. 1.06. What is the ratio of the Employment (as % of female employment) of Services in 1988 to that in 1991?
Provide a succinct answer. 0.98. What is the ratio of the Employment (as % of female employment) in Self-employed in 1988 to that in 1991?
Provide a short and direct response. 1.02. What is the ratio of the Employment (as % of female employment) of Agriculture in 1988 to that in 1992?
Your answer should be very brief. 1.26. What is the ratio of the Employment (as % of female employment) of Industry in 1988 to that in 1992?
Make the answer very short. 1.08. What is the ratio of the Employment (as % of female employment) of Services in 1988 to that in 1992?
Provide a short and direct response. 0.98. What is the ratio of the Employment (as % of female employment) in Self-employed in 1988 to that in 1992?
Provide a short and direct response. 1.07. What is the ratio of the Employment (as % of female employment) of Agriculture in 1988 to that in 1993?
Make the answer very short. 1.26. What is the ratio of the Employment (as % of female employment) of Industry in 1988 to that in 1993?
Offer a terse response. 1.03. What is the ratio of the Employment (as % of female employment) of Services in 1988 to that in 1993?
Keep it short and to the point. 0.99. What is the ratio of the Employment (as % of female employment) in Agriculture in 1989 to that in 1990?
Keep it short and to the point. 1.04. What is the ratio of the Employment (as % of female employment) of Services in 1989 to that in 1990?
Your answer should be very brief. 1. What is the ratio of the Employment (as % of female employment) of Self-employed in 1989 to that in 1990?
Your response must be concise. 1.02. What is the ratio of the Employment (as % of female employment) of Agriculture in 1989 to that in 1991?
Keep it short and to the point. 1.26. What is the ratio of the Employment (as % of female employment) in Industry in 1989 to that in 1991?
Provide a short and direct response. 1.01. What is the ratio of the Employment (as % of female employment) of Services in 1989 to that in 1991?
Your answer should be very brief. 0.99. What is the ratio of the Employment (as % of female employment) of Self-employed in 1989 to that in 1991?
Your answer should be compact. 0.98. What is the ratio of the Employment (as % of female employment) of Agriculture in 1989 to that in 1992?
Keep it short and to the point. 1.26. What is the ratio of the Employment (as % of female employment) of Industry in 1989 to that in 1992?
Your answer should be very brief. 1.02. What is the ratio of the Employment (as % of female employment) in Self-employed in 1989 to that in 1992?
Provide a succinct answer. 1.02. What is the ratio of the Employment (as % of female employment) of Agriculture in 1989 to that in 1993?
Offer a terse response. 1.26. What is the ratio of the Employment (as % of female employment) of Industry in 1989 to that in 1993?
Offer a very short reply. 0.98. What is the ratio of the Employment (as % of female employment) in Services in 1989 to that in 1993?
Your response must be concise. 1. What is the ratio of the Employment (as % of female employment) of Self-employed in 1989 to that in 1993?
Your answer should be compact. 1.05. What is the ratio of the Employment (as % of female employment) of Agriculture in 1990 to that in 1991?
Offer a very short reply. 1.21. What is the ratio of the Employment (as % of female employment) of Industry in 1990 to that in 1991?
Offer a very short reply. 1.01. What is the ratio of the Employment (as % of female employment) in Services in 1990 to that in 1991?
Give a very brief answer. 0.99. What is the ratio of the Employment (as % of female employment) in Self-employed in 1990 to that in 1991?
Provide a short and direct response. 0.95. What is the ratio of the Employment (as % of female employment) in Agriculture in 1990 to that in 1992?
Your response must be concise. 1.21. What is the ratio of the Employment (as % of female employment) in Industry in 1990 to that in 1992?
Keep it short and to the point. 1.03. What is the ratio of the Employment (as % of female employment) in Services in 1990 to that in 1992?
Keep it short and to the point. 0.99. What is the ratio of the Employment (as % of female employment) in Self-employed in 1990 to that in 1992?
Provide a short and direct response. 1. What is the ratio of the Employment (as % of female employment) in Agriculture in 1990 to that in 1993?
Provide a succinct answer. 1.21. What is the ratio of the Employment (as % of female employment) of Industry in 1990 to that in 1993?
Your answer should be compact. 0.99. What is the ratio of the Employment (as % of female employment) in Services in 1990 to that in 1993?
Provide a succinct answer. 1. What is the ratio of the Employment (as % of female employment) in Self-employed in 1990 to that in 1993?
Make the answer very short. 1.02. What is the ratio of the Employment (as % of female employment) of Agriculture in 1991 to that in 1992?
Your answer should be compact. 1. What is the ratio of the Employment (as % of female employment) in Industry in 1991 to that in 1992?
Offer a very short reply. 1.01. What is the ratio of the Employment (as % of female employment) of Self-employed in 1991 to that in 1992?
Provide a succinct answer. 1.05. What is the ratio of the Employment (as % of female employment) of Industry in 1991 to that in 1993?
Provide a short and direct response. 0.97. What is the ratio of the Employment (as % of female employment) of Self-employed in 1991 to that in 1993?
Your response must be concise. 1.07. What is the ratio of the Employment (as % of female employment) in Industry in 1992 to that in 1993?
Keep it short and to the point. 0.96. What is the ratio of the Employment (as % of female employment) in Services in 1992 to that in 1993?
Keep it short and to the point. 1. What is the difference between the highest and the second highest Employment (as % of female employment) of Agriculture?
Offer a very short reply. 0.3. What is the difference between the highest and the second highest Employment (as % of female employment) in Industry?
Keep it short and to the point. 0.2. What is the difference between the highest and the second highest Employment (as % of female employment) in Self-employed?
Keep it short and to the point. 0.2. What is the difference between the highest and the lowest Employment (as % of female employment) in Industry?
Ensure brevity in your answer.  1.7. 